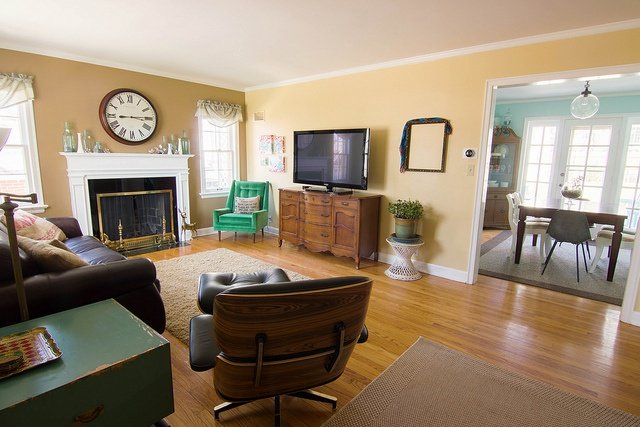Describe the objects in this image and their specific colors. I can see chair in ivory, black, maroon, and olive tones, dining table in ivory, gray, and brown tones, tv in ivory, gray, black, darkgray, and lightgray tones, couch in ivory, black, and gray tones, and dining table in ivory, white, black, and gray tones in this image. 